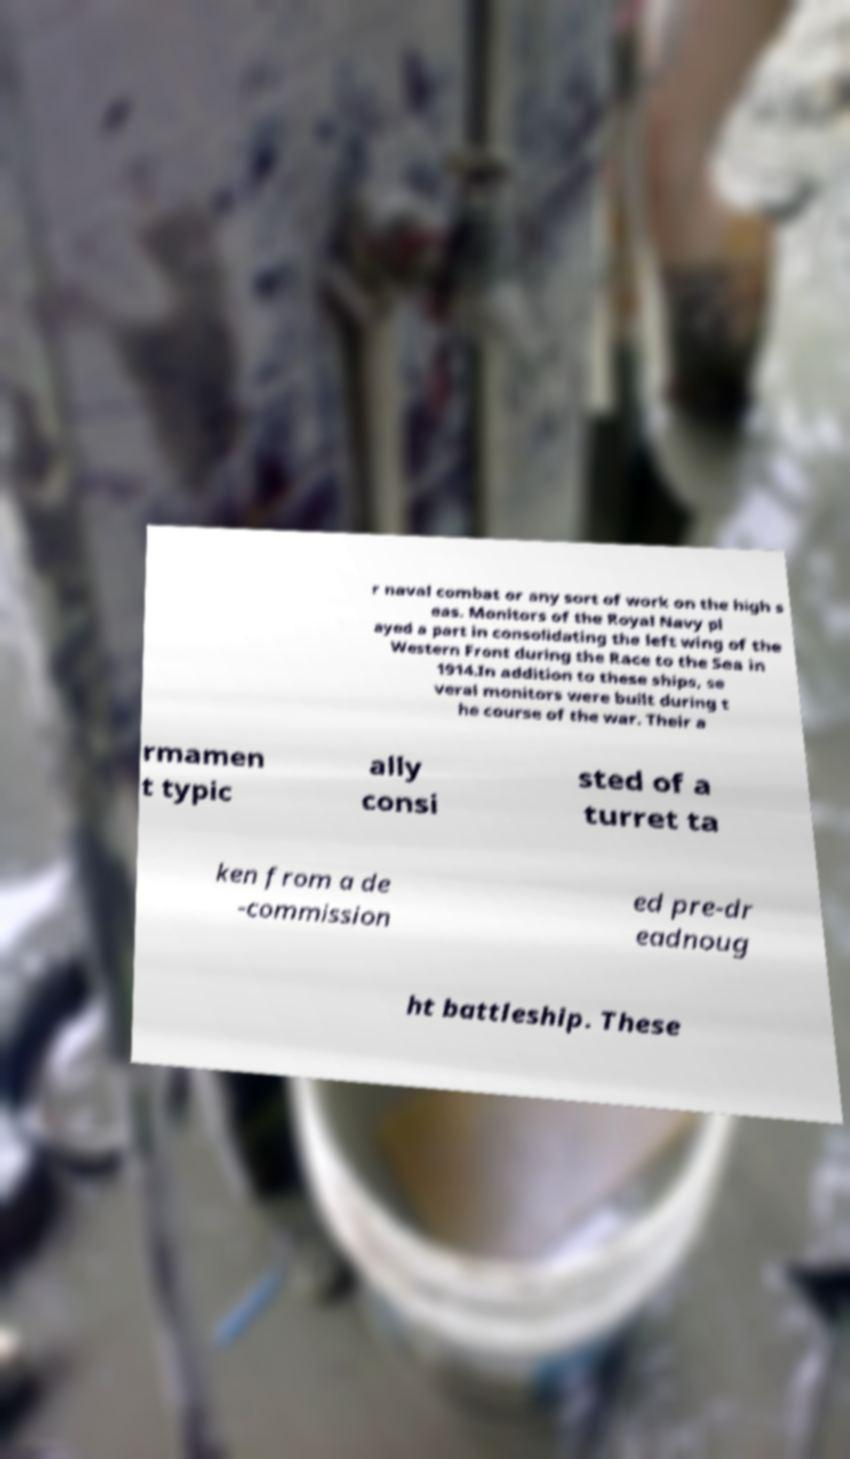Please read and relay the text visible in this image. What does it say? r naval combat or any sort of work on the high s eas. Monitors of the Royal Navy pl ayed a part in consolidating the left wing of the Western Front during the Race to the Sea in 1914.In addition to these ships, se veral monitors were built during t he course of the war. Their a rmamen t typic ally consi sted of a turret ta ken from a de -commission ed pre-dr eadnoug ht battleship. These 